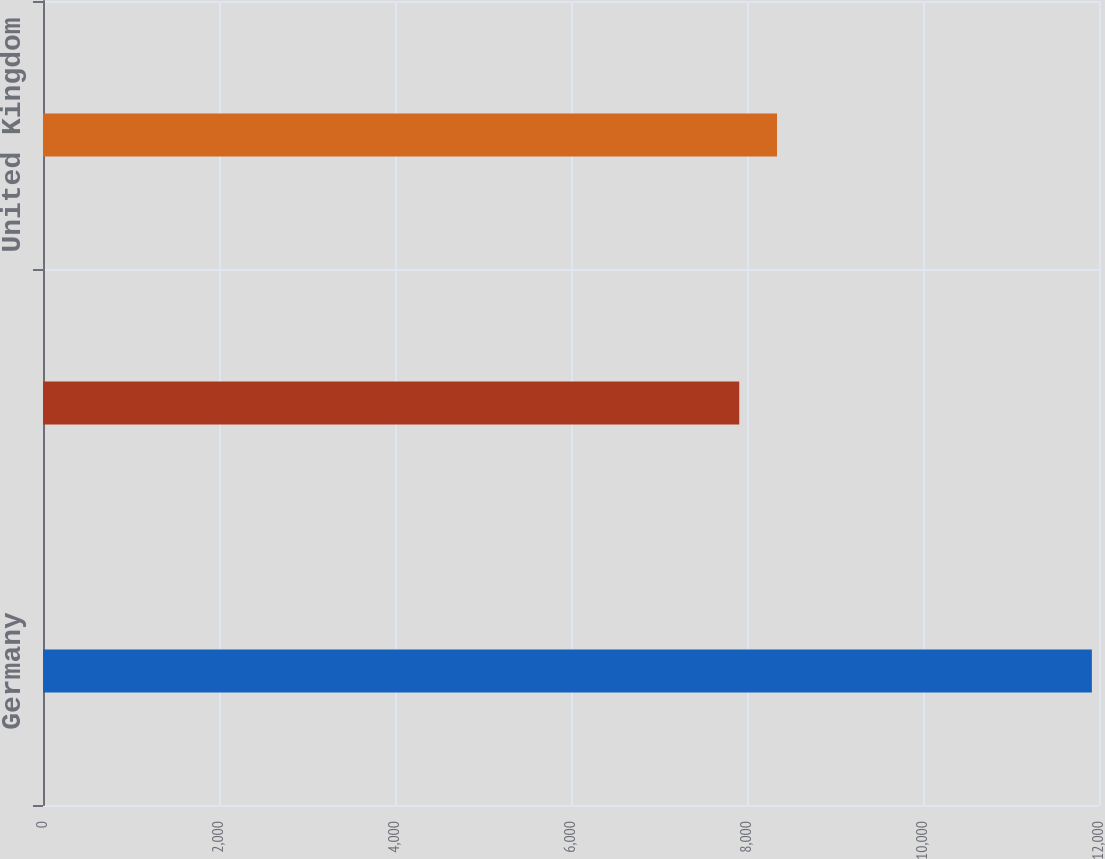Convert chart. <chart><loc_0><loc_0><loc_500><loc_500><bar_chart><fcel>Germany<fcel>Japan<fcel>United Kingdom<nl><fcel>11919<fcel>7912<fcel>8341<nl></chart> 